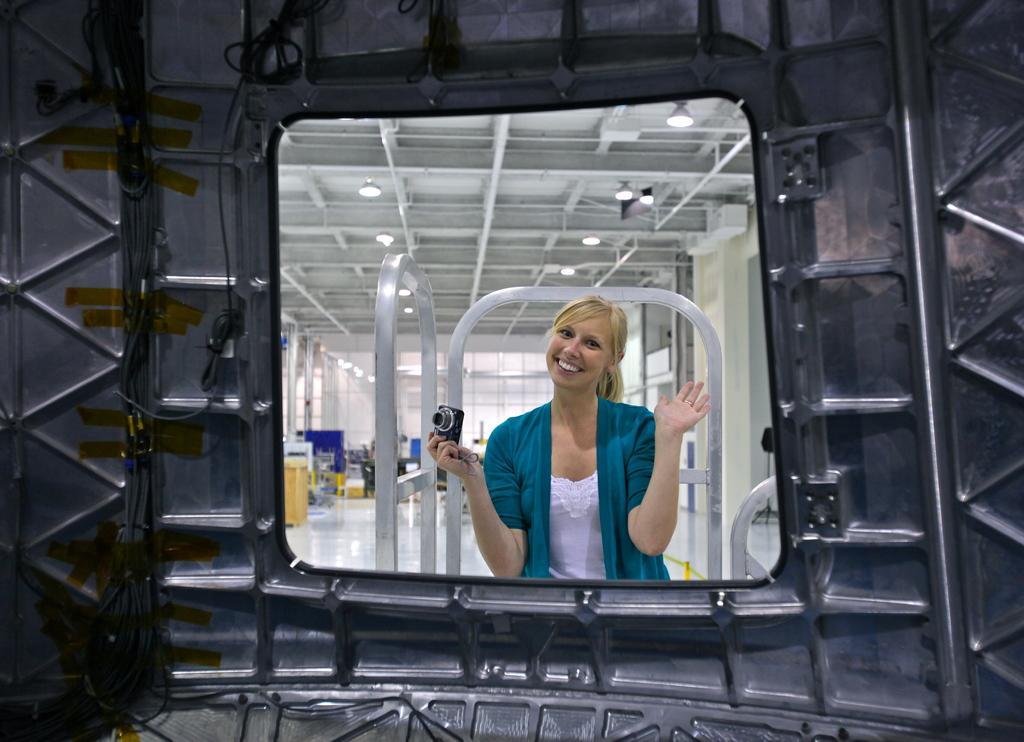How would you summarize this image in a sentence or two? In this image a woman wearing a jacket is holding a camera in her hand. She is behind the metal wall. There are few objects in the room. Few lights are attached to the roof. 